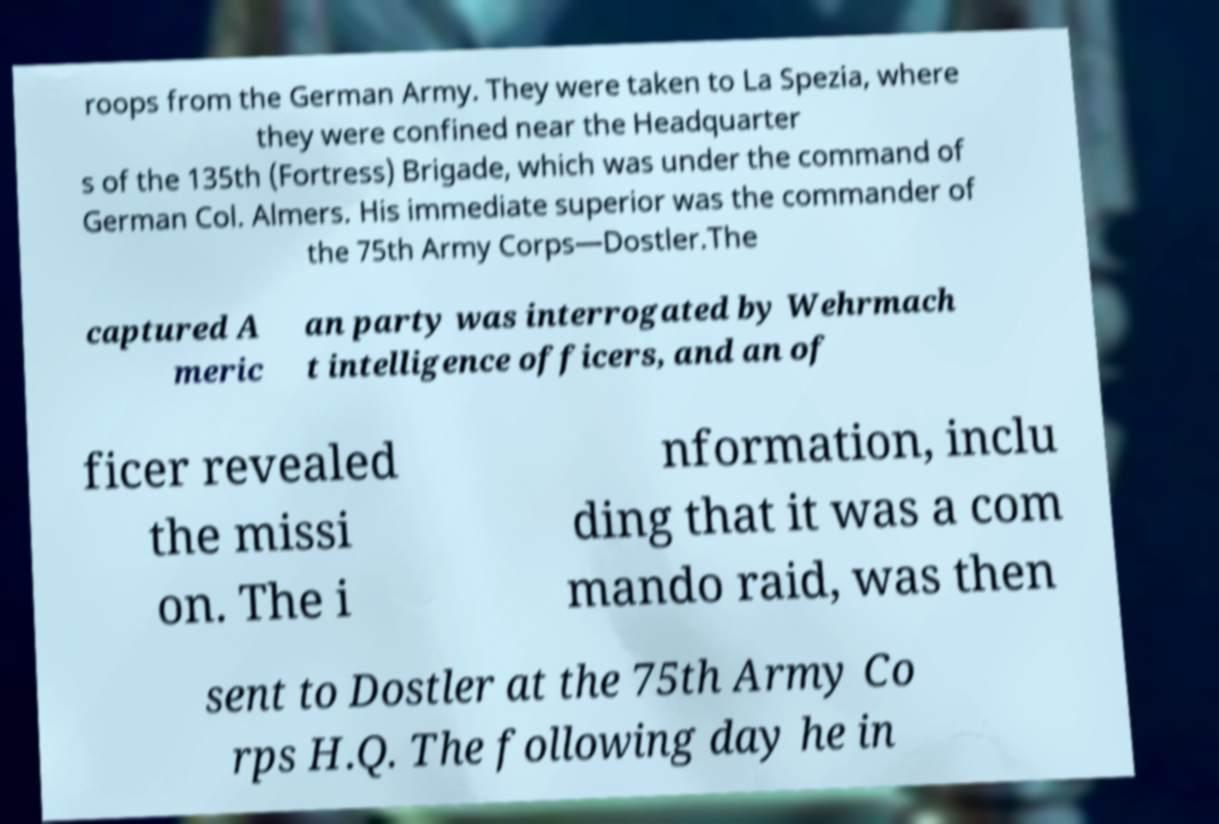What messages or text are displayed in this image? I need them in a readable, typed format. roops from the German Army. They were taken to La Spezia, where they were confined near the Headquarter s of the 135th (Fortress) Brigade, which was under the command of German Col. Almers. His immediate superior was the commander of the 75th Army Corps—Dostler.The captured A meric an party was interrogated by Wehrmach t intelligence officers, and an of ficer revealed the missi on. The i nformation, inclu ding that it was a com mando raid, was then sent to Dostler at the 75th Army Co rps H.Q. The following day he in 